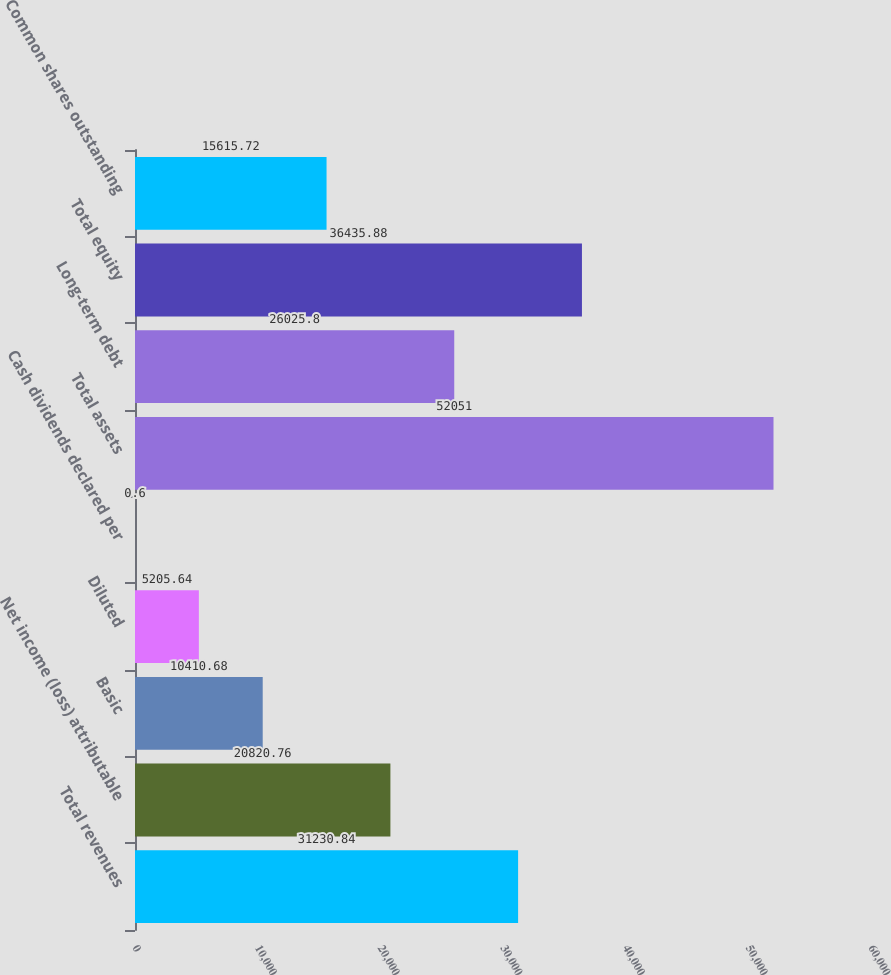Convert chart. <chart><loc_0><loc_0><loc_500><loc_500><bar_chart><fcel>Total revenues<fcel>Net income (loss) attributable<fcel>Basic<fcel>Diluted<fcel>Cash dividends declared per<fcel>Total assets<fcel>Long-term debt<fcel>Total equity<fcel>Common shares outstanding<nl><fcel>31230.8<fcel>20820.8<fcel>10410.7<fcel>5205.64<fcel>0.6<fcel>52051<fcel>26025.8<fcel>36435.9<fcel>15615.7<nl></chart> 